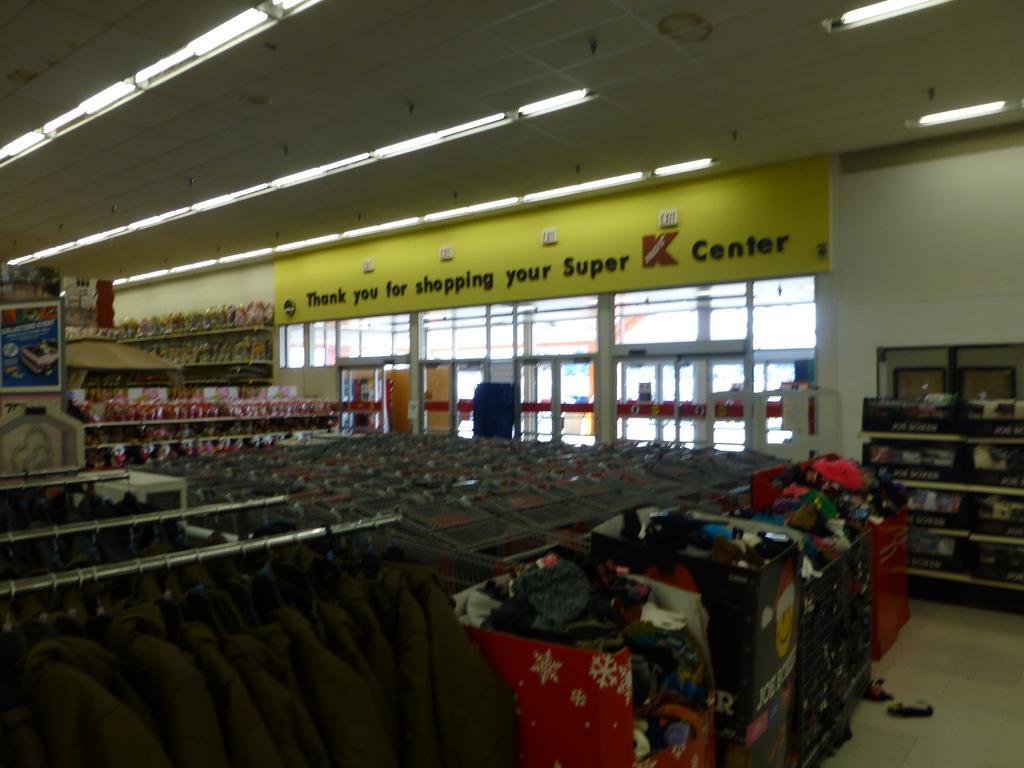Could you give a brief overview of what you see in this image? In this image, I can see the clothes hanging to the hangers, wheel carts and objects in the racks. I can see the glass doors and a name board. At the top of the image, there are lights attached to the ceiling. 